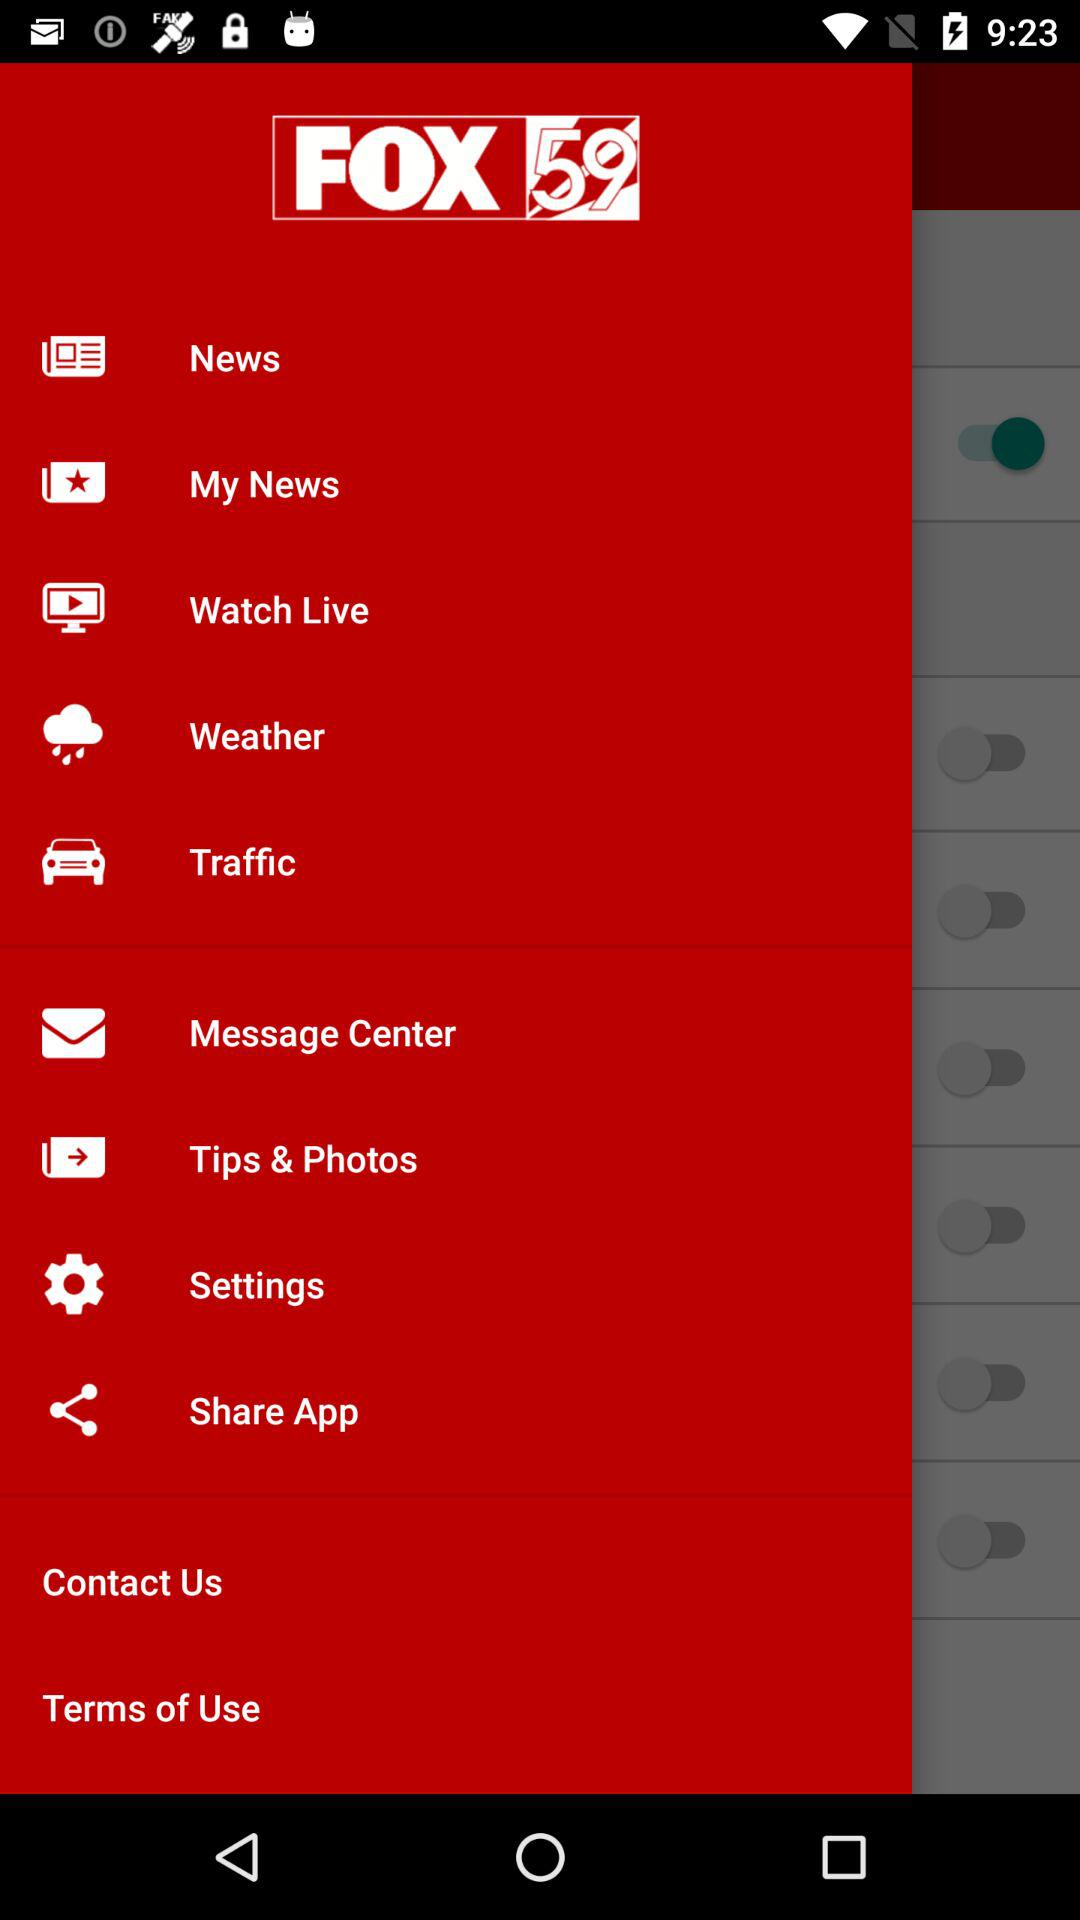What is the application name? The application name is FOX 59. 